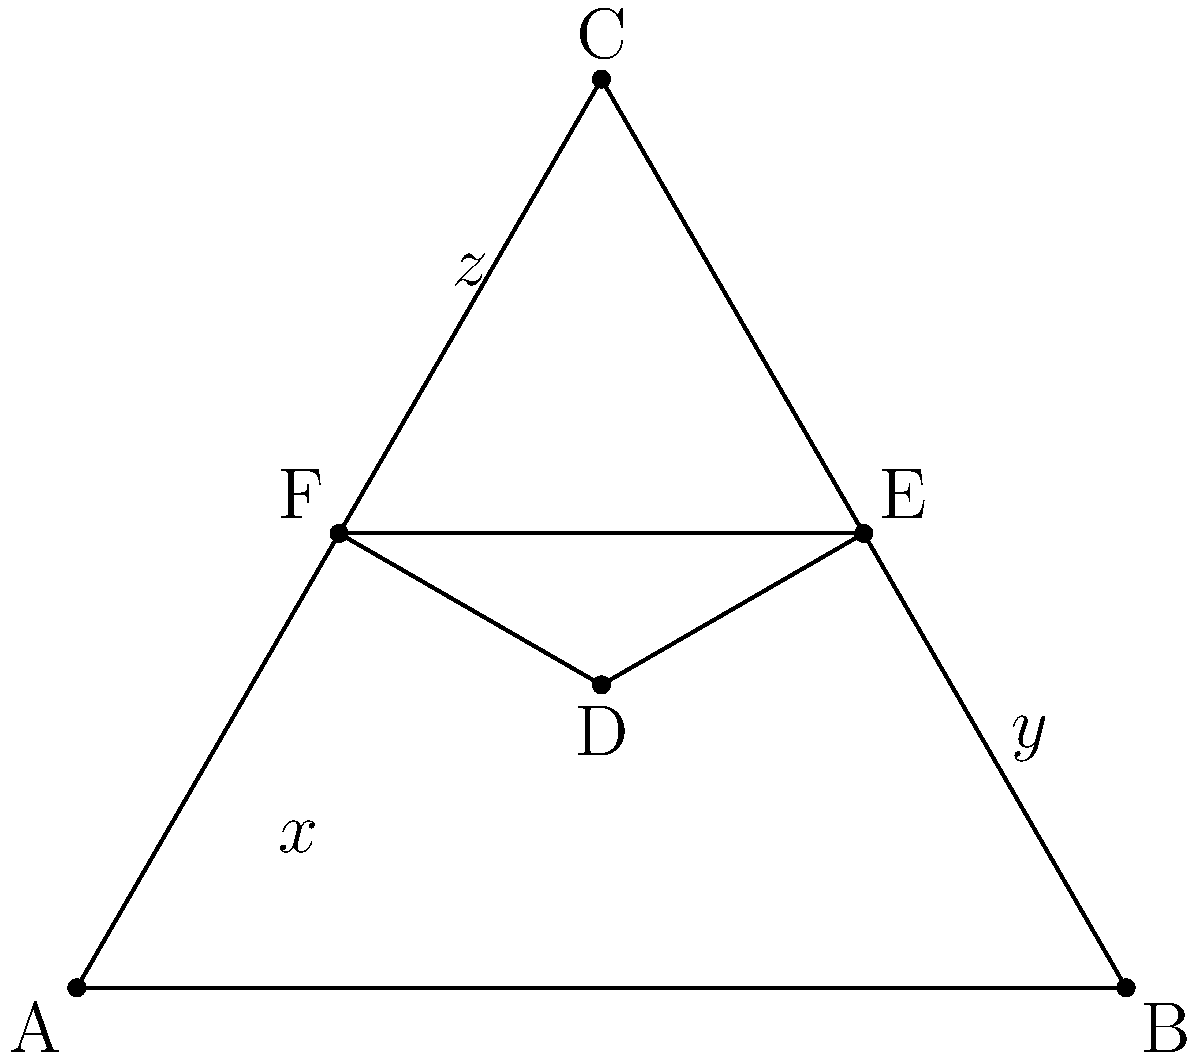In the Star of David shown above, triangle ABC is similar to triangle DEF. If the ratio of the area of triangle DEF to the area of triangle ABC is 1:4, and the length of AD is $x$, BE is $y$, and CF is $z$, express $x + y + z$ in terms of the side length of triangle ABC. Let's approach this step-by-step:

1) In similar triangles, the ratio of their areas is equal to the square of the ratio of their corresponding sides. If the area ratio is 1:4, then the side ratio is 1:2.

2) This means that each side of triangle DEF is half the length of the corresponding side of triangle ABC.

3) Let's denote the side length of triangle ABC as $s$. Then:
   AD + DF = s
   BE + EF = s
   CF + CD = s

4) Since D, E, and F are midpoints of the sides of triangle ABC:
   AD = DF = $\frac{s}{2}$
   BE = EF = $\frac{s}{2}$
   CF = CD = $\frac{s}{2}$

5) Therefore:
   $x = AD = \frac{s}{2}$
   $y = BE = \frac{s}{2}$
   $z = CF = \frac{s}{2}$

6) The sum $x + y + z$ is thus:
   $x + y + z = \frac{s}{2} + \frac{s}{2} + \frac{s}{2} = \frac{3s}{2}$

Therefore, the sum of $x$, $y$, and $z$ is equal to $\frac{3}{2}$ times the side length of triangle ABC.
Answer: $\frac{3s}{2}$ 